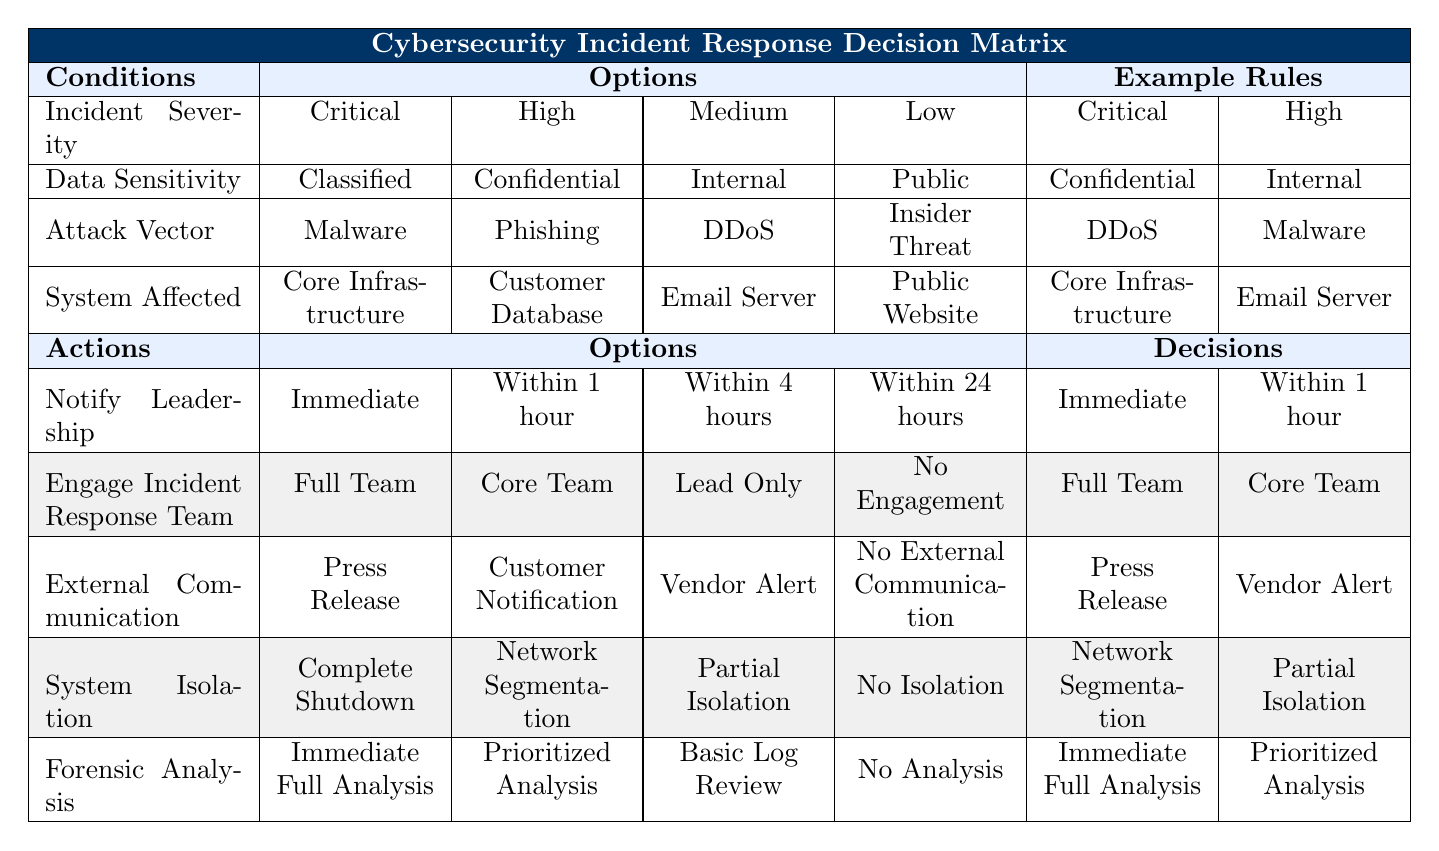What actions should be taken when the incident severity is Critical, the data sensitivity is Classified, and the attack vector is Malware? The table indicates that for these conditions, the required actions are Notify Leadership immediately, engage the full incident response team, issue a press release, complete system shutdown, and conduct an immediate full analysis.
Answer: Immediate, Full Team, Press Release, Complete Shutdown, Immediate Full Analysis Is it necessary to notify leadership within 1 hour when the incident severity is High and the data sensitivity is Confidential? According to the table, the specified actions for this scenario clearly state that leadership should be notified within 1 hour. Therefore, it is necessary.
Answer: Yes Which action is taken regarding external communication when the incident severity is Medium, the data sensitivity is Internal, and the attack vector is DDoS? The rule for these specific conditions indicates that the action is to issue a Vendor Alert for external communication.
Answer: Vendor Alert What is the maximum delay allowed in notifying leadership for Low severity incidents involving Public data with an Insider Threat? The rules specify that for Low severity incidents, leadership should be notified within 24 hours. This is the maximum delay allowed for such incidents.
Answer: Within 24 hours If both the incident severity is High and the attack vector is Phishing, what is the total number of different actions that must be taken? The combination of High severity and Phishing gives us one rule that mentions five specific actions: Notify Leadership within 1 hour, Engage Core Team, External Communication through Customer Notification, System Isolation through Network Segmentation, and Forensic Analysis through Prioritized Analysis. Hence, the total number of actions is 5.
Answer: 5 If the attack vector is Malware and the system affected is the Email Server, how soon should leadership be notified? The table does not provide any specific rules for this scenario, thus we need to check other rows. The High severity with Malware affecting the Email Server specifies notifying leadership within 1 hour, which is the most logical conclusion we can infer given the conditions.
Answer: Within 1 hour 